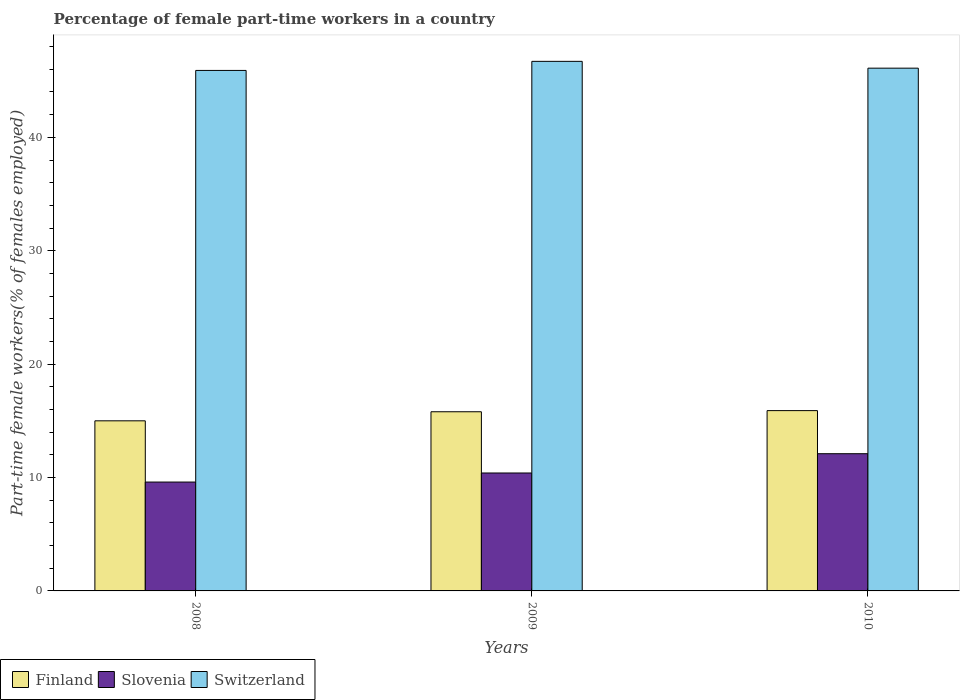How many different coloured bars are there?
Provide a succinct answer. 3. Are the number of bars on each tick of the X-axis equal?
Your answer should be very brief. Yes. What is the percentage of female part-time workers in Switzerland in 2008?
Offer a very short reply. 45.9. Across all years, what is the maximum percentage of female part-time workers in Switzerland?
Provide a succinct answer. 46.7. Across all years, what is the minimum percentage of female part-time workers in Switzerland?
Provide a succinct answer. 45.9. What is the total percentage of female part-time workers in Switzerland in the graph?
Your answer should be compact. 138.7. What is the difference between the percentage of female part-time workers in Slovenia in 2009 and that in 2010?
Offer a terse response. -1.7. What is the difference between the percentage of female part-time workers in Switzerland in 2008 and the percentage of female part-time workers in Slovenia in 2010?
Ensure brevity in your answer.  33.8. What is the average percentage of female part-time workers in Switzerland per year?
Make the answer very short. 46.23. In the year 2008, what is the difference between the percentage of female part-time workers in Slovenia and percentage of female part-time workers in Finland?
Offer a very short reply. -5.4. In how many years, is the percentage of female part-time workers in Slovenia greater than 10 %?
Your answer should be compact. 2. What is the ratio of the percentage of female part-time workers in Finland in 2008 to that in 2010?
Provide a succinct answer. 0.94. Is the difference between the percentage of female part-time workers in Slovenia in 2009 and 2010 greater than the difference between the percentage of female part-time workers in Finland in 2009 and 2010?
Give a very brief answer. No. What is the difference between the highest and the second highest percentage of female part-time workers in Slovenia?
Your answer should be compact. 1.7. What is the difference between the highest and the lowest percentage of female part-time workers in Finland?
Offer a very short reply. 0.9. What does the 2nd bar from the right in 2008 represents?
Ensure brevity in your answer.  Slovenia. Does the graph contain grids?
Offer a very short reply. No. Where does the legend appear in the graph?
Your response must be concise. Bottom left. How many legend labels are there?
Your response must be concise. 3. What is the title of the graph?
Offer a very short reply. Percentage of female part-time workers in a country. Does "Algeria" appear as one of the legend labels in the graph?
Provide a short and direct response. No. What is the label or title of the X-axis?
Your answer should be very brief. Years. What is the label or title of the Y-axis?
Offer a very short reply. Part-time female workers(% of females employed). What is the Part-time female workers(% of females employed) in Slovenia in 2008?
Give a very brief answer. 9.6. What is the Part-time female workers(% of females employed) in Switzerland in 2008?
Provide a short and direct response. 45.9. What is the Part-time female workers(% of females employed) of Finland in 2009?
Provide a short and direct response. 15.8. What is the Part-time female workers(% of females employed) of Slovenia in 2009?
Provide a short and direct response. 10.4. What is the Part-time female workers(% of females employed) in Switzerland in 2009?
Provide a succinct answer. 46.7. What is the Part-time female workers(% of females employed) of Finland in 2010?
Your answer should be very brief. 15.9. What is the Part-time female workers(% of females employed) of Slovenia in 2010?
Provide a succinct answer. 12.1. What is the Part-time female workers(% of females employed) in Switzerland in 2010?
Provide a short and direct response. 46.1. Across all years, what is the maximum Part-time female workers(% of females employed) of Finland?
Your answer should be compact. 15.9. Across all years, what is the maximum Part-time female workers(% of females employed) in Slovenia?
Provide a short and direct response. 12.1. Across all years, what is the maximum Part-time female workers(% of females employed) in Switzerland?
Provide a short and direct response. 46.7. Across all years, what is the minimum Part-time female workers(% of females employed) in Finland?
Offer a very short reply. 15. Across all years, what is the minimum Part-time female workers(% of females employed) of Slovenia?
Provide a succinct answer. 9.6. Across all years, what is the minimum Part-time female workers(% of females employed) of Switzerland?
Make the answer very short. 45.9. What is the total Part-time female workers(% of females employed) in Finland in the graph?
Your answer should be very brief. 46.7. What is the total Part-time female workers(% of females employed) of Slovenia in the graph?
Your answer should be compact. 32.1. What is the total Part-time female workers(% of females employed) of Switzerland in the graph?
Your response must be concise. 138.7. What is the difference between the Part-time female workers(% of females employed) of Finland in 2008 and that in 2009?
Give a very brief answer. -0.8. What is the difference between the Part-time female workers(% of females employed) of Switzerland in 2008 and that in 2009?
Your response must be concise. -0.8. What is the difference between the Part-time female workers(% of females employed) in Finland in 2008 and that in 2010?
Provide a short and direct response. -0.9. What is the difference between the Part-time female workers(% of females employed) of Finland in 2009 and that in 2010?
Your answer should be compact. -0.1. What is the difference between the Part-time female workers(% of females employed) in Finland in 2008 and the Part-time female workers(% of females employed) in Slovenia in 2009?
Offer a terse response. 4.6. What is the difference between the Part-time female workers(% of females employed) of Finland in 2008 and the Part-time female workers(% of females employed) of Switzerland in 2009?
Provide a succinct answer. -31.7. What is the difference between the Part-time female workers(% of females employed) in Slovenia in 2008 and the Part-time female workers(% of females employed) in Switzerland in 2009?
Provide a short and direct response. -37.1. What is the difference between the Part-time female workers(% of females employed) of Finland in 2008 and the Part-time female workers(% of females employed) of Switzerland in 2010?
Offer a terse response. -31.1. What is the difference between the Part-time female workers(% of females employed) in Slovenia in 2008 and the Part-time female workers(% of females employed) in Switzerland in 2010?
Offer a very short reply. -36.5. What is the difference between the Part-time female workers(% of females employed) of Finland in 2009 and the Part-time female workers(% of females employed) of Slovenia in 2010?
Your response must be concise. 3.7. What is the difference between the Part-time female workers(% of females employed) in Finland in 2009 and the Part-time female workers(% of females employed) in Switzerland in 2010?
Give a very brief answer. -30.3. What is the difference between the Part-time female workers(% of females employed) of Slovenia in 2009 and the Part-time female workers(% of females employed) of Switzerland in 2010?
Give a very brief answer. -35.7. What is the average Part-time female workers(% of females employed) of Finland per year?
Offer a very short reply. 15.57. What is the average Part-time female workers(% of females employed) of Switzerland per year?
Ensure brevity in your answer.  46.23. In the year 2008, what is the difference between the Part-time female workers(% of females employed) in Finland and Part-time female workers(% of females employed) in Switzerland?
Keep it short and to the point. -30.9. In the year 2008, what is the difference between the Part-time female workers(% of females employed) of Slovenia and Part-time female workers(% of females employed) of Switzerland?
Provide a short and direct response. -36.3. In the year 2009, what is the difference between the Part-time female workers(% of females employed) of Finland and Part-time female workers(% of females employed) of Slovenia?
Give a very brief answer. 5.4. In the year 2009, what is the difference between the Part-time female workers(% of females employed) in Finland and Part-time female workers(% of females employed) in Switzerland?
Provide a succinct answer. -30.9. In the year 2009, what is the difference between the Part-time female workers(% of females employed) of Slovenia and Part-time female workers(% of females employed) of Switzerland?
Give a very brief answer. -36.3. In the year 2010, what is the difference between the Part-time female workers(% of females employed) of Finland and Part-time female workers(% of females employed) of Switzerland?
Your answer should be very brief. -30.2. In the year 2010, what is the difference between the Part-time female workers(% of females employed) in Slovenia and Part-time female workers(% of females employed) in Switzerland?
Your response must be concise. -34. What is the ratio of the Part-time female workers(% of females employed) of Finland in 2008 to that in 2009?
Give a very brief answer. 0.95. What is the ratio of the Part-time female workers(% of females employed) of Slovenia in 2008 to that in 2009?
Offer a terse response. 0.92. What is the ratio of the Part-time female workers(% of females employed) in Switzerland in 2008 to that in 2009?
Keep it short and to the point. 0.98. What is the ratio of the Part-time female workers(% of females employed) of Finland in 2008 to that in 2010?
Offer a terse response. 0.94. What is the ratio of the Part-time female workers(% of females employed) of Slovenia in 2008 to that in 2010?
Give a very brief answer. 0.79. What is the ratio of the Part-time female workers(% of females employed) of Finland in 2009 to that in 2010?
Your answer should be very brief. 0.99. What is the ratio of the Part-time female workers(% of females employed) in Slovenia in 2009 to that in 2010?
Provide a short and direct response. 0.86. What is the ratio of the Part-time female workers(% of females employed) in Switzerland in 2009 to that in 2010?
Your answer should be compact. 1.01. What is the difference between the highest and the second highest Part-time female workers(% of females employed) in Finland?
Provide a short and direct response. 0.1. What is the difference between the highest and the second highest Part-time female workers(% of females employed) of Slovenia?
Keep it short and to the point. 1.7. What is the difference between the highest and the lowest Part-time female workers(% of females employed) of Finland?
Provide a short and direct response. 0.9. What is the difference between the highest and the lowest Part-time female workers(% of females employed) in Switzerland?
Your answer should be compact. 0.8. 